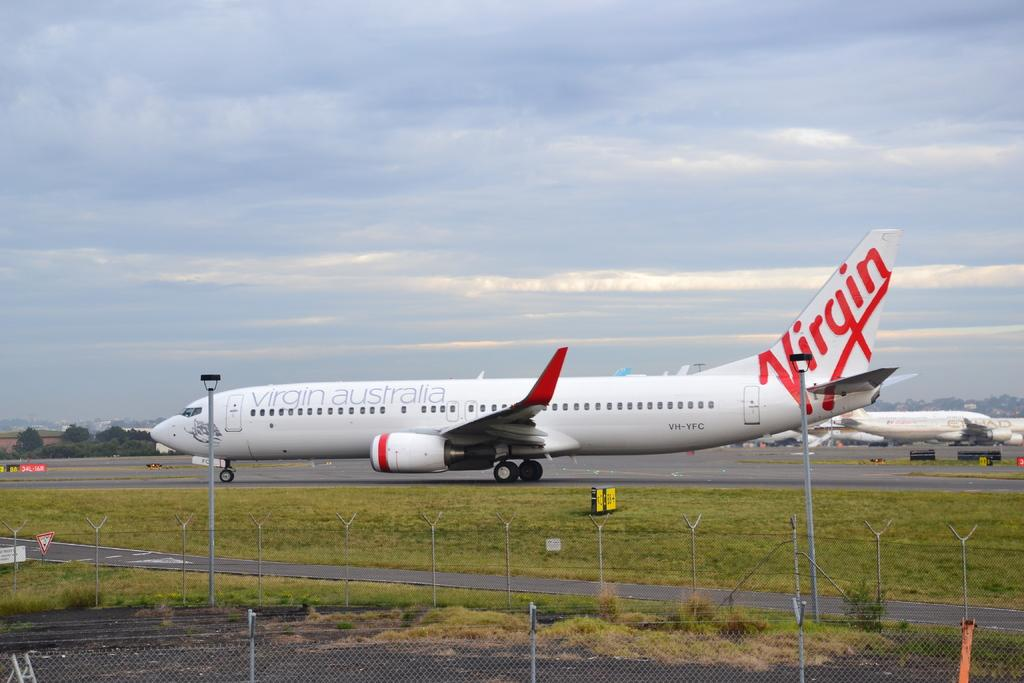What type of vehicles are on the ground in the image? There are airplanes on the ground in the image. What structures can be seen in the image? There are poles and boards visible in the image. What type of vegetation is present in the image? There are trees and grass in the image. What other objects can be seen in the image? There are other objects in the image, but their specific details are not mentioned in the provided facts. What is visible in the background of the image? The sky with clouds is visible in the background of the image. Can you see a guitar being played in the image? There is no guitar or any musical instrument being played in the image. Is there an eye visible on any of the airplanes in the image? There is no eye or any facial feature present on the airplanes in the image. 